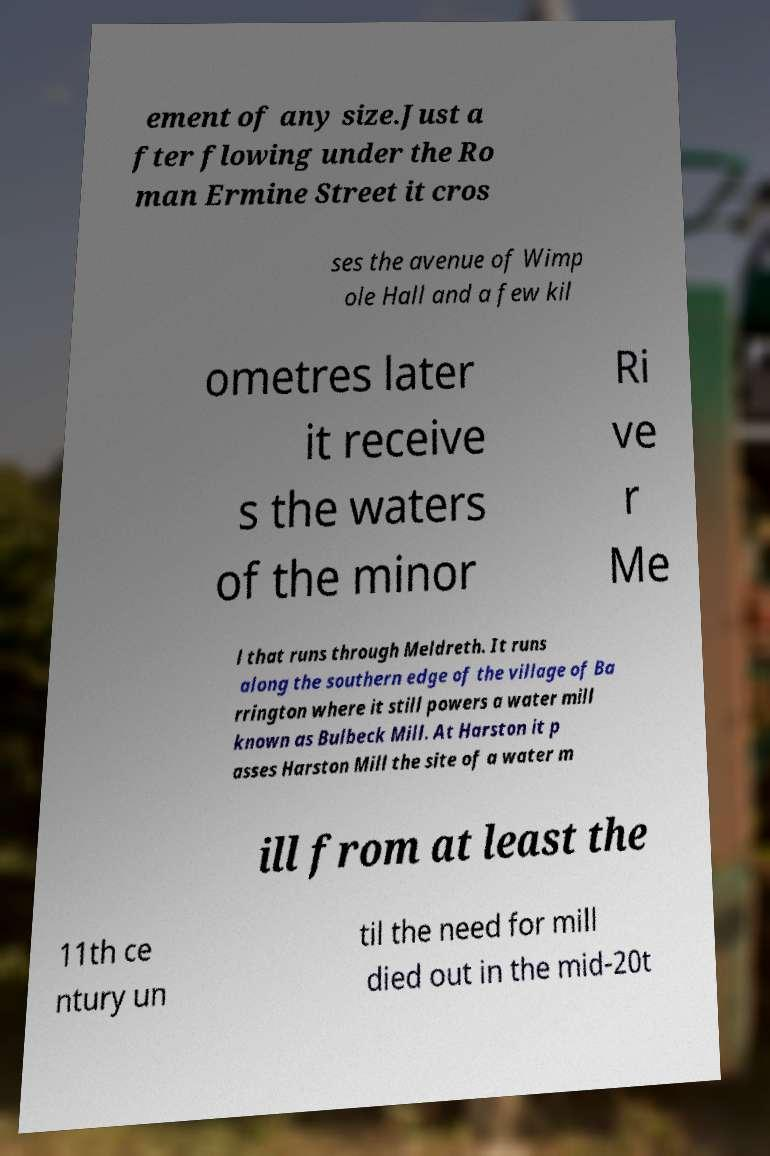For documentation purposes, I need the text within this image transcribed. Could you provide that? ement of any size.Just a fter flowing under the Ro man Ermine Street it cros ses the avenue of Wimp ole Hall and a few kil ometres later it receive s the waters of the minor Ri ve r Me l that runs through Meldreth. It runs along the southern edge of the village of Ba rrington where it still powers a water mill known as Bulbeck Mill. At Harston it p asses Harston Mill the site of a water m ill from at least the 11th ce ntury un til the need for mill died out in the mid-20t 